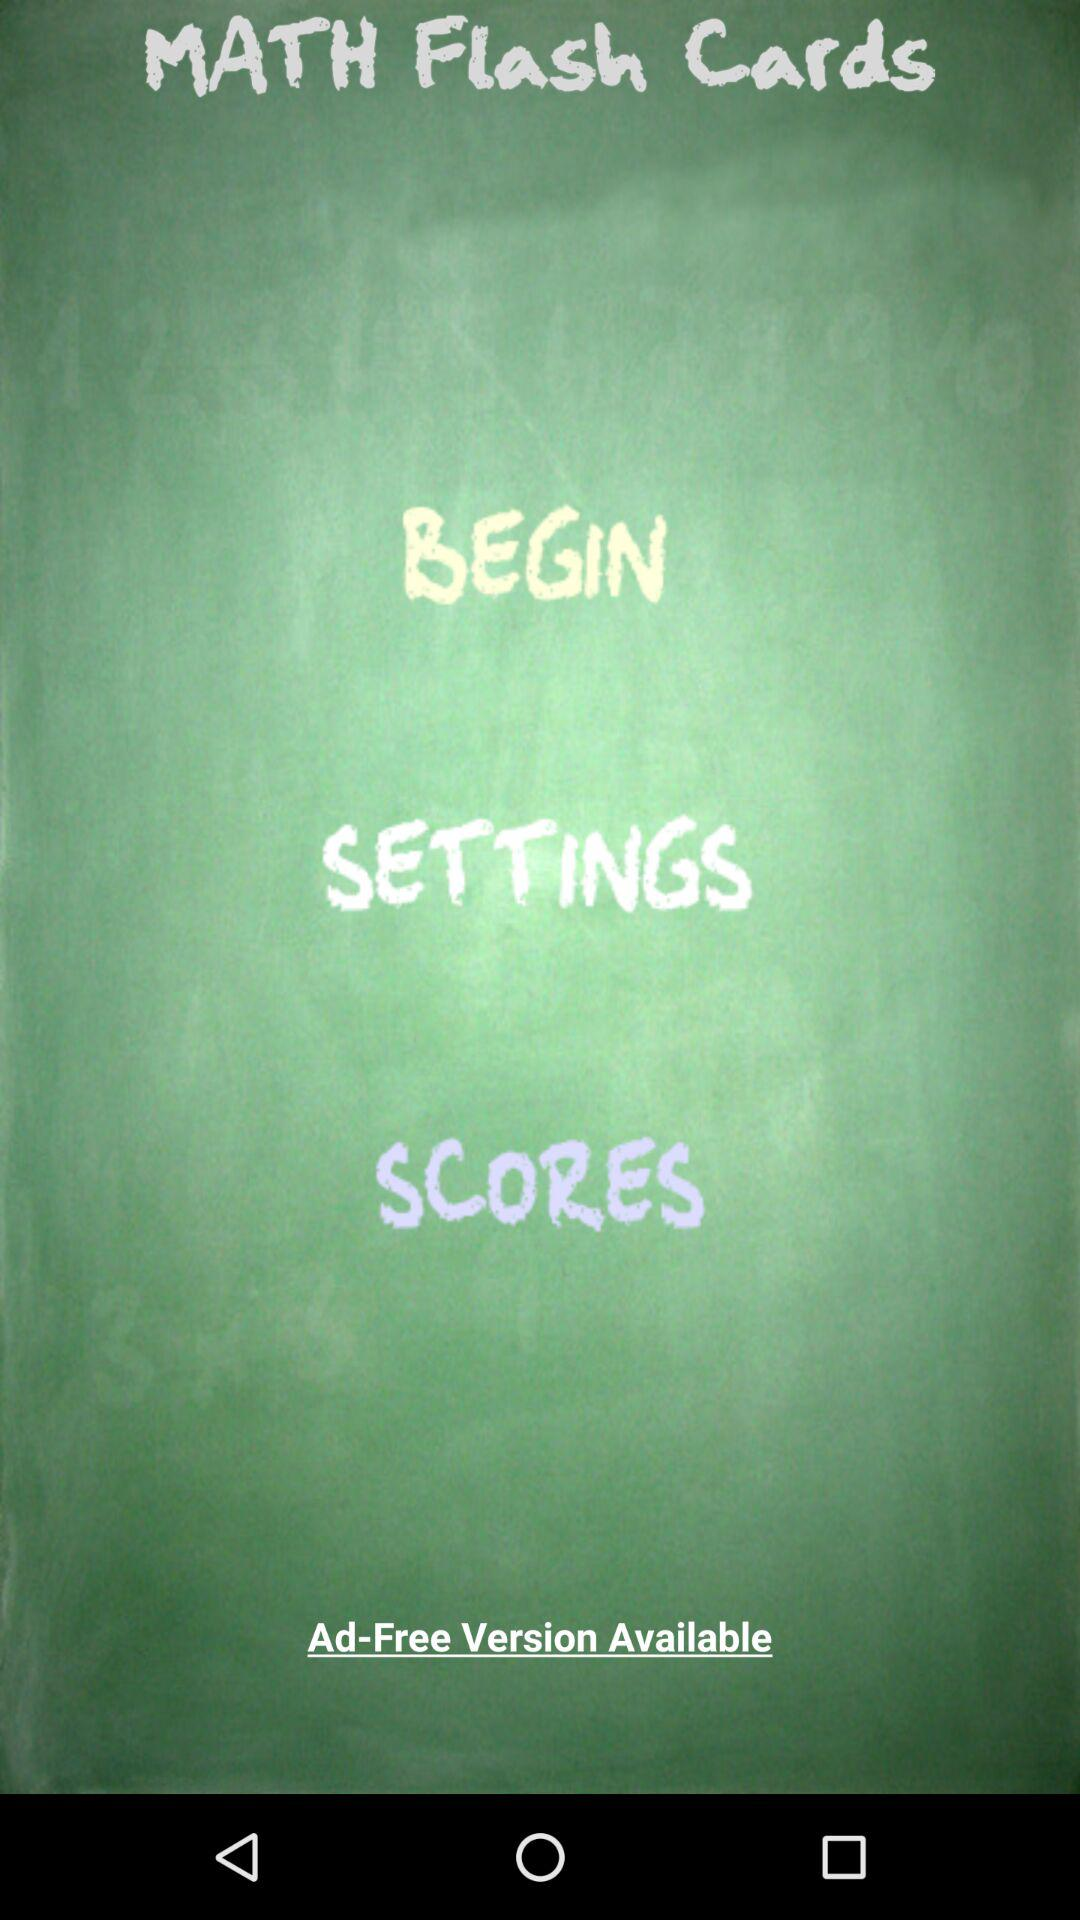What is the application name? The application name is "MATH Flash Cards". 